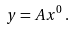<formula> <loc_0><loc_0><loc_500><loc_500>y = A x ^ { 0 } \, .</formula> 